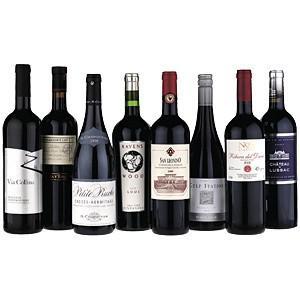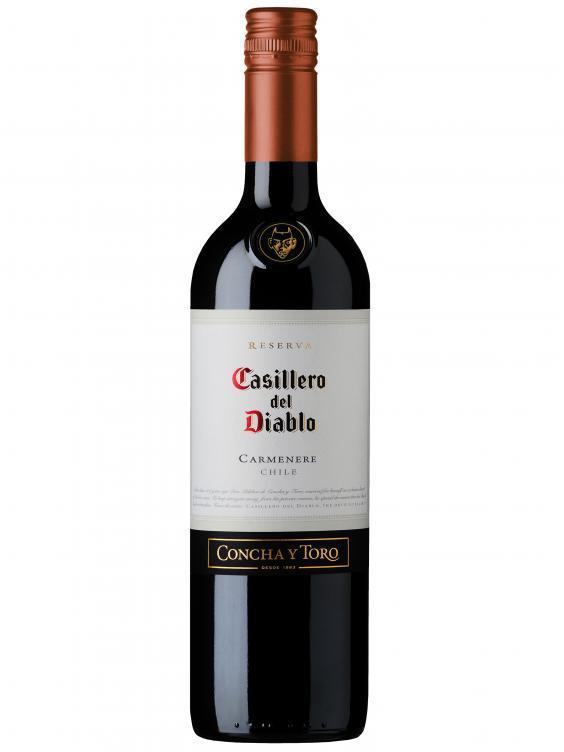The first image is the image on the left, the second image is the image on the right. For the images displayed, is the sentence "there are at least seven wine bottles in the image on the left" factually correct? Answer yes or no. Yes. The first image is the image on the left, the second image is the image on the right. Given the left and right images, does the statement "An image shows a horizontal row of at least 7 bottles, with no space between bottles." hold true? Answer yes or no. Yes. 